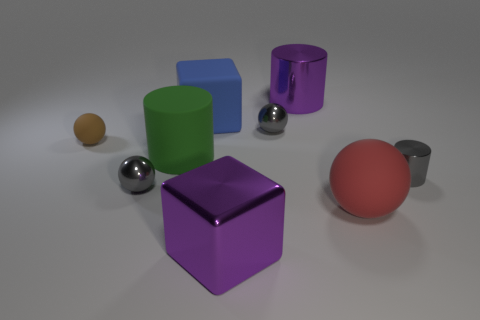Subtract all red spheres. How many spheres are left? 3 Subtract all green cylinders. How many cylinders are left? 2 Subtract all cylinders. How many objects are left? 6 Subtract 1 balls. How many balls are left? 3 Subtract all purple spheres. Subtract all cyan cubes. How many spheres are left? 4 Subtract all cyan balls. How many blue blocks are left? 1 Subtract all gray things. Subtract all purple metallic cylinders. How many objects are left? 5 Add 9 brown things. How many brown things are left? 10 Add 6 rubber things. How many rubber things exist? 10 Subtract 0 red cylinders. How many objects are left? 9 